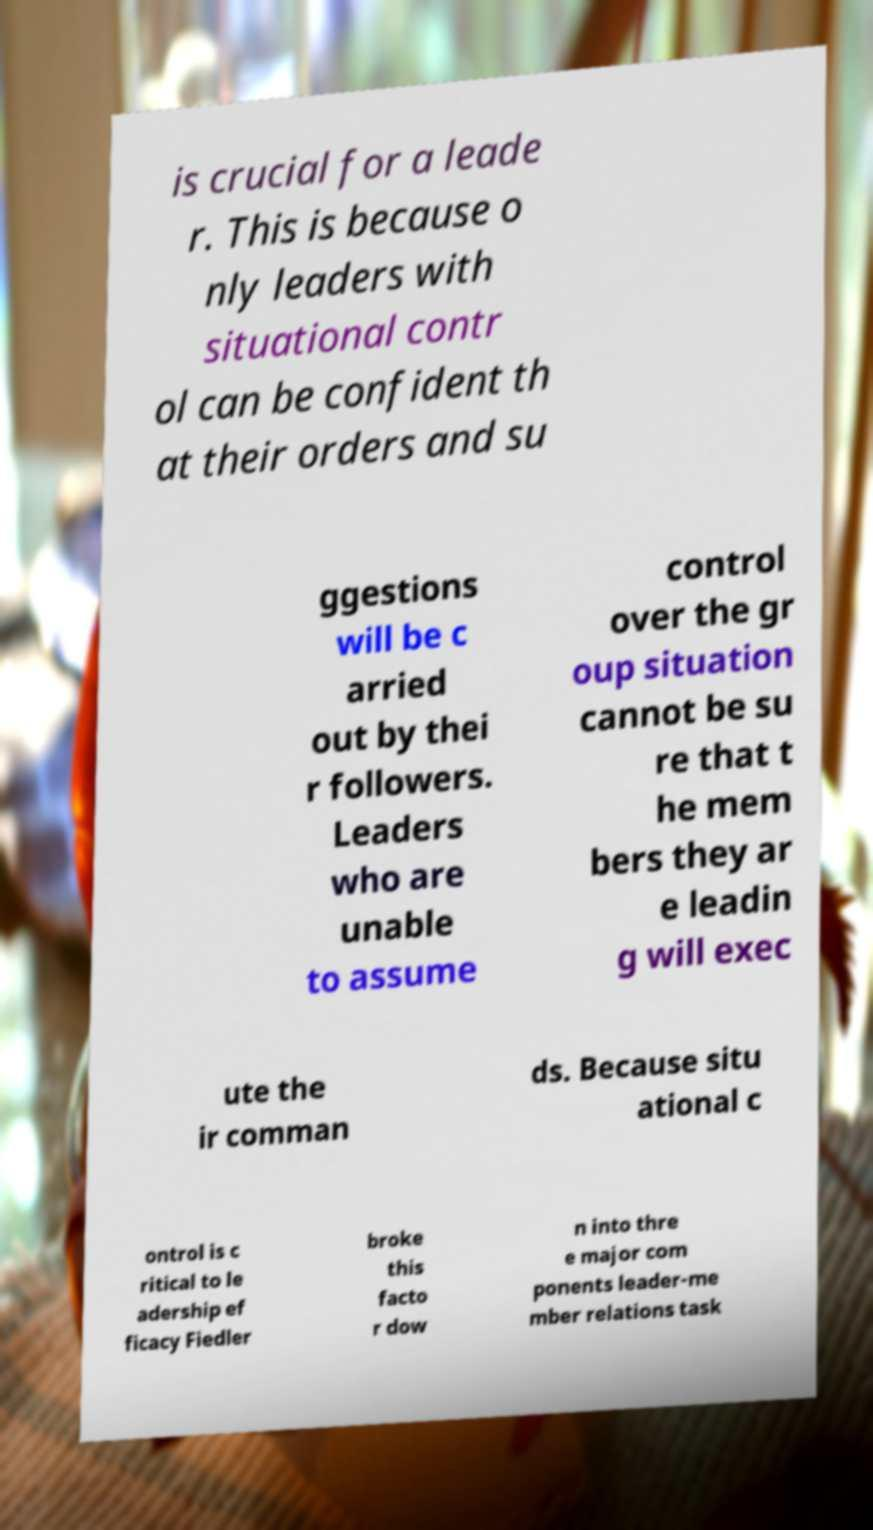Could you assist in decoding the text presented in this image and type it out clearly? is crucial for a leade r. This is because o nly leaders with situational contr ol can be confident th at their orders and su ggestions will be c arried out by thei r followers. Leaders who are unable to assume control over the gr oup situation cannot be su re that t he mem bers they ar e leadin g will exec ute the ir comman ds. Because situ ational c ontrol is c ritical to le adership ef ficacy Fiedler broke this facto r dow n into thre e major com ponents leader-me mber relations task 